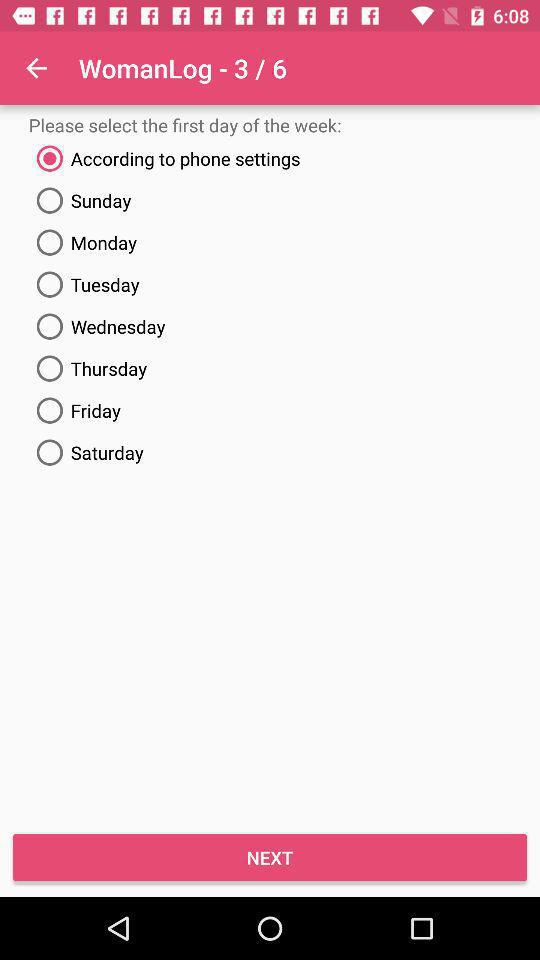How many "WomanLog" in total are there? There are 6 "WomanLog" in total. 